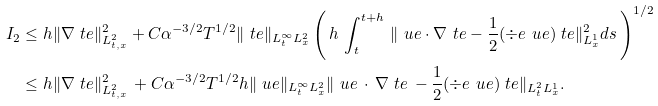Convert formula to latex. <formula><loc_0><loc_0><loc_500><loc_500>I _ { 2 } & \leq h \| \nabla \ t e \| ^ { 2 } _ { L ^ { 2 } _ { t , x } } + C \alpha ^ { - 3 / 2 } T ^ { 1 / 2 } \| \ t e \| _ { L ^ { \infty } _ { t } L ^ { 2 } _ { x } } \left ( \, h \, \int _ { t } ^ { t + h } \, \| \ u e \cdot \nabla \ t e - \frac { 1 } { 2 } ( \div e \ u e ) \ t e \| ^ { 2 } _ { L ^ { 1 } _ { x } } d s \, \right ) ^ { 1 / 2 } \\ & \leq h \| \nabla \ t e \| ^ { 2 } _ { L ^ { 2 } _ { t , x } } \, + C \alpha ^ { - 3 / 2 } T ^ { 1 / 2 } h \| \ u e \| _ { L ^ { \infty } _ { t } L ^ { 2 } _ { x } } \| \ u e \, \cdot \, \nabla \ t e \, - \frac { 1 } { 2 } ( \div e \ u e ) \ t e \| _ { L ^ { 2 } _ { t } L ^ { 1 } _ { x } } .</formula> 